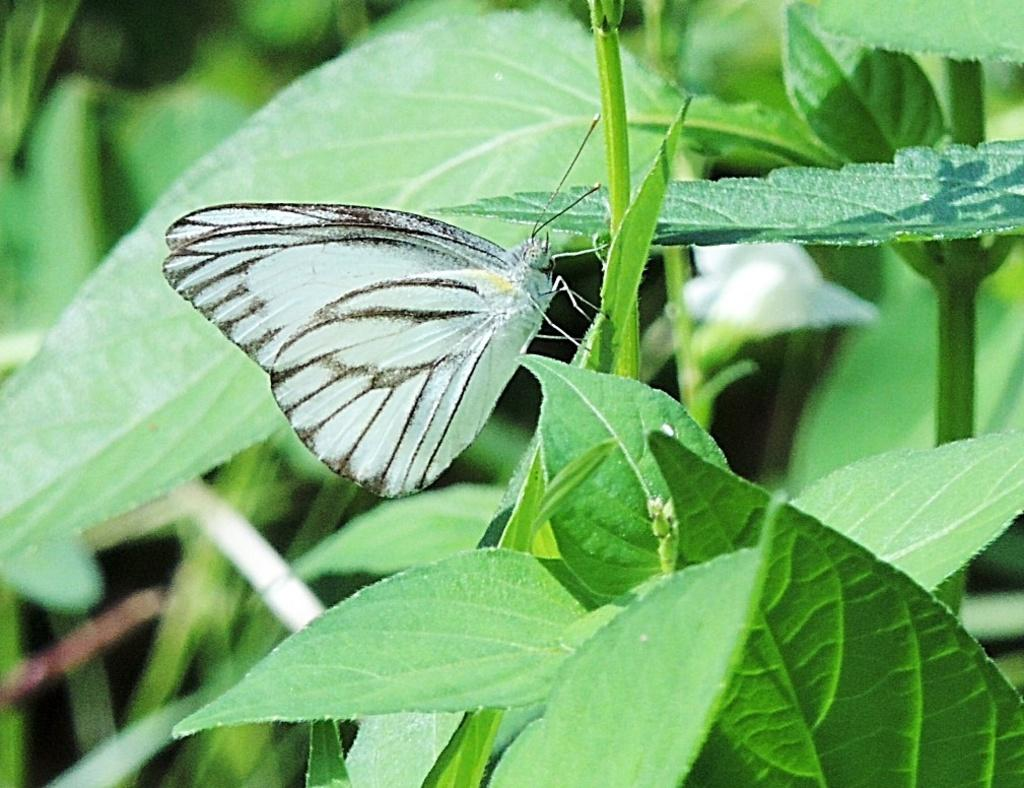What is the main subject of the image? There is a butterfly in the image. Where is the butterfly located? The butterfly is on the stem of a plant. What can be seen in the background of the image? There is a flower in the background of the image. What is the color of the flower? The flower is white in color. What else can be seen in the image besides the butterfly and flower? There are leaves visible in the image. How many elbows can be seen in the image? There are no elbows present in the image. What type of pin is holding the butterfly to the stem? There is no pin holding the butterfly to the stem; it is resting on the stem naturally. 